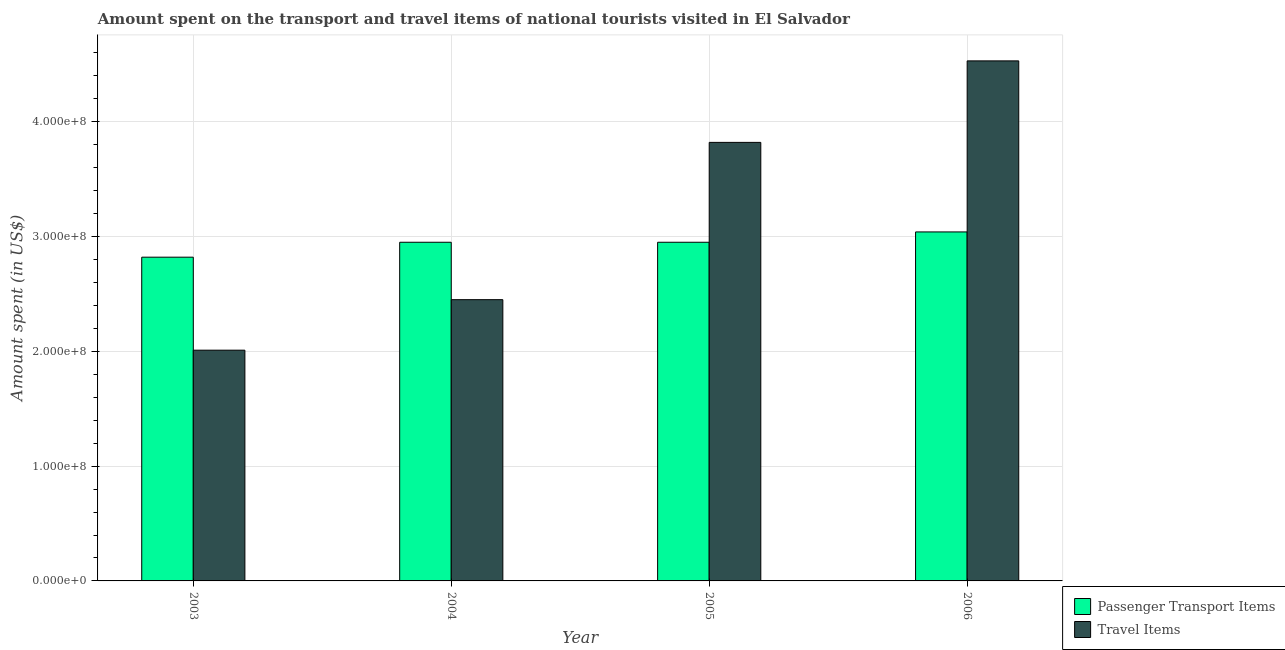How many different coloured bars are there?
Offer a terse response. 2. Are the number of bars on each tick of the X-axis equal?
Offer a very short reply. Yes. How many bars are there on the 2nd tick from the right?
Your answer should be very brief. 2. What is the amount spent on passenger transport items in 2004?
Offer a very short reply. 2.95e+08. Across all years, what is the maximum amount spent in travel items?
Ensure brevity in your answer.  4.53e+08. Across all years, what is the minimum amount spent in travel items?
Offer a very short reply. 2.01e+08. In which year was the amount spent in travel items minimum?
Ensure brevity in your answer.  2003. What is the total amount spent in travel items in the graph?
Your answer should be very brief. 1.28e+09. What is the difference between the amount spent on passenger transport items in 2004 and that in 2005?
Make the answer very short. 0. What is the difference between the amount spent on passenger transport items in 2005 and the amount spent in travel items in 2004?
Ensure brevity in your answer.  0. What is the average amount spent on passenger transport items per year?
Offer a very short reply. 2.94e+08. In how many years, is the amount spent in travel items greater than 260000000 US$?
Offer a very short reply. 2. What is the ratio of the amount spent in travel items in 2004 to that in 2006?
Provide a short and direct response. 0.54. What is the difference between the highest and the second highest amount spent in travel items?
Make the answer very short. 7.10e+07. What is the difference between the highest and the lowest amount spent on passenger transport items?
Make the answer very short. 2.20e+07. In how many years, is the amount spent on passenger transport items greater than the average amount spent on passenger transport items taken over all years?
Provide a short and direct response. 3. What does the 1st bar from the left in 2005 represents?
Ensure brevity in your answer.  Passenger Transport Items. What does the 1st bar from the right in 2003 represents?
Ensure brevity in your answer.  Travel Items. How many bars are there?
Provide a short and direct response. 8. Are all the bars in the graph horizontal?
Give a very brief answer. No. How many years are there in the graph?
Provide a short and direct response. 4. What is the difference between two consecutive major ticks on the Y-axis?
Offer a very short reply. 1.00e+08. Does the graph contain any zero values?
Your answer should be compact. No. How many legend labels are there?
Your answer should be very brief. 2. What is the title of the graph?
Provide a short and direct response. Amount spent on the transport and travel items of national tourists visited in El Salvador. What is the label or title of the X-axis?
Give a very brief answer. Year. What is the label or title of the Y-axis?
Give a very brief answer. Amount spent (in US$). What is the Amount spent (in US$) in Passenger Transport Items in 2003?
Give a very brief answer. 2.82e+08. What is the Amount spent (in US$) in Travel Items in 2003?
Ensure brevity in your answer.  2.01e+08. What is the Amount spent (in US$) of Passenger Transport Items in 2004?
Your answer should be compact. 2.95e+08. What is the Amount spent (in US$) of Travel Items in 2004?
Provide a short and direct response. 2.45e+08. What is the Amount spent (in US$) of Passenger Transport Items in 2005?
Your answer should be compact. 2.95e+08. What is the Amount spent (in US$) in Travel Items in 2005?
Your response must be concise. 3.82e+08. What is the Amount spent (in US$) of Passenger Transport Items in 2006?
Ensure brevity in your answer.  3.04e+08. What is the Amount spent (in US$) in Travel Items in 2006?
Provide a succinct answer. 4.53e+08. Across all years, what is the maximum Amount spent (in US$) of Passenger Transport Items?
Offer a terse response. 3.04e+08. Across all years, what is the maximum Amount spent (in US$) of Travel Items?
Provide a succinct answer. 4.53e+08. Across all years, what is the minimum Amount spent (in US$) of Passenger Transport Items?
Offer a very short reply. 2.82e+08. Across all years, what is the minimum Amount spent (in US$) in Travel Items?
Keep it short and to the point. 2.01e+08. What is the total Amount spent (in US$) of Passenger Transport Items in the graph?
Provide a short and direct response. 1.18e+09. What is the total Amount spent (in US$) in Travel Items in the graph?
Make the answer very short. 1.28e+09. What is the difference between the Amount spent (in US$) of Passenger Transport Items in 2003 and that in 2004?
Keep it short and to the point. -1.30e+07. What is the difference between the Amount spent (in US$) of Travel Items in 2003 and that in 2004?
Your response must be concise. -4.40e+07. What is the difference between the Amount spent (in US$) in Passenger Transport Items in 2003 and that in 2005?
Give a very brief answer. -1.30e+07. What is the difference between the Amount spent (in US$) of Travel Items in 2003 and that in 2005?
Ensure brevity in your answer.  -1.81e+08. What is the difference between the Amount spent (in US$) in Passenger Transport Items in 2003 and that in 2006?
Provide a succinct answer. -2.20e+07. What is the difference between the Amount spent (in US$) in Travel Items in 2003 and that in 2006?
Provide a succinct answer. -2.52e+08. What is the difference between the Amount spent (in US$) of Passenger Transport Items in 2004 and that in 2005?
Provide a short and direct response. 0. What is the difference between the Amount spent (in US$) in Travel Items in 2004 and that in 2005?
Provide a succinct answer. -1.37e+08. What is the difference between the Amount spent (in US$) in Passenger Transport Items in 2004 and that in 2006?
Provide a succinct answer. -9.00e+06. What is the difference between the Amount spent (in US$) of Travel Items in 2004 and that in 2006?
Your answer should be compact. -2.08e+08. What is the difference between the Amount spent (in US$) of Passenger Transport Items in 2005 and that in 2006?
Offer a terse response. -9.00e+06. What is the difference between the Amount spent (in US$) of Travel Items in 2005 and that in 2006?
Ensure brevity in your answer.  -7.10e+07. What is the difference between the Amount spent (in US$) in Passenger Transport Items in 2003 and the Amount spent (in US$) in Travel Items in 2004?
Your answer should be compact. 3.70e+07. What is the difference between the Amount spent (in US$) of Passenger Transport Items in 2003 and the Amount spent (in US$) of Travel Items in 2005?
Make the answer very short. -1.00e+08. What is the difference between the Amount spent (in US$) of Passenger Transport Items in 2003 and the Amount spent (in US$) of Travel Items in 2006?
Make the answer very short. -1.71e+08. What is the difference between the Amount spent (in US$) of Passenger Transport Items in 2004 and the Amount spent (in US$) of Travel Items in 2005?
Your answer should be very brief. -8.70e+07. What is the difference between the Amount spent (in US$) of Passenger Transport Items in 2004 and the Amount spent (in US$) of Travel Items in 2006?
Provide a short and direct response. -1.58e+08. What is the difference between the Amount spent (in US$) of Passenger Transport Items in 2005 and the Amount spent (in US$) of Travel Items in 2006?
Provide a succinct answer. -1.58e+08. What is the average Amount spent (in US$) of Passenger Transport Items per year?
Offer a very short reply. 2.94e+08. What is the average Amount spent (in US$) in Travel Items per year?
Make the answer very short. 3.20e+08. In the year 2003, what is the difference between the Amount spent (in US$) in Passenger Transport Items and Amount spent (in US$) in Travel Items?
Your answer should be compact. 8.10e+07. In the year 2004, what is the difference between the Amount spent (in US$) of Passenger Transport Items and Amount spent (in US$) of Travel Items?
Keep it short and to the point. 5.00e+07. In the year 2005, what is the difference between the Amount spent (in US$) of Passenger Transport Items and Amount spent (in US$) of Travel Items?
Your answer should be compact. -8.70e+07. In the year 2006, what is the difference between the Amount spent (in US$) in Passenger Transport Items and Amount spent (in US$) in Travel Items?
Your answer should be very brief. -1.49e+08. What is the ratio of the Amount spent (in US$) of Passenger Transport Items in 2003 to that in 2004?
Make the answer very short. 0.96. What is the ratio of the Amount spent (in US$) in Travel Items in 2003 to that in 2004?
Provide a succinct answer. 0.82. What is the ratio of the Amount spent (in US$) of Passenger Transport Items in 2003 to that in 2005?
Your response must be concise. 0.96. What is the ratio of the Amount spent (in US$) in Travel Items in 2003 to that in 2005?
Your answer should be very brief. 0.53. What is the ratio of the Amount spent (in US$) of Passenger Transport Items in 2003 to that in 2006?
Ensure brevity in your answer.  0.93. What is the ratio of the Amount spent (in US$) of Travel Items in 2003 to that in 2006?
Offer a very short reply. 0.44. What is the ratio of the Amount spent (in US$) of Passenger Transport Items in 2004 to that in 2005?
Ensure brevity in your answer.  1. What is the ratio of the Amount spent (in US$) of Travel Items in 2004 to that in 2005?
Ensure brevity in your answer.  0.64. What is the ratio of the Amount spent (in US$) of Passenger Transport Items in 2004 to that in 2006?
Your answer should be very brief. 0.97. What is the ratio of the Amount spent (in US$) in Travel Items in 2004 to that in 2006?
Your response must be concise. 0.54. What is the ratio of the Amount spent (in US$) of Passenger Transport Items in 2005 to that in 2006?
Your answer should be compact. 0.97. What is the ratio of the Amount spent (in US$) in Travel Items in 2005 to that in 2006?
Provide a short and direct response. 0.84. What is the difference between the highest and the second highest Amount spent (in US$) of Passenger Transport Items?
Offer a very short reply. 9.00e+06. What is the difference between the highest and the second highest Amount spent (in US$) in Travel Items?
Offer a terse response. 7.10e+07. What is the difference between the highest and the lowest Amount spent (in US$) of Passenger Transport Items?
Your answer should be very brief. 2.20e+07. What is the difference between the highest and the lowest Amount spent (in US$) of Travel Items?
Offer a terse response. 2.52e+08. 